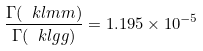<formula> <loc_0><loc_0><loc_500><loc_500>\frac { \Gamma ( \ k l m m ) } { \Gamma ( \ k l g g ) } = 1 . 1 9 5 \times 1 0 ^ { - 5 }</formula> 